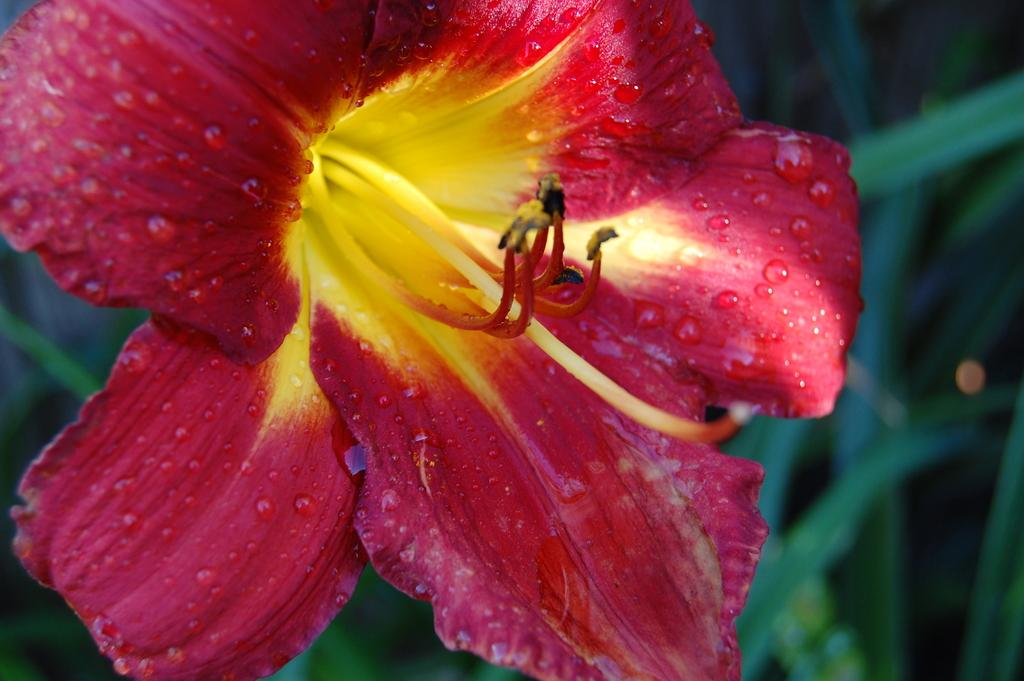What is the main subject of the image? There is a flower in the image. What else can be seen in the background of the image? There are leaves visible in the background of the image. How would you describe the quality of the image? The image is blurry. What arithmetic problem is being solved by the cats in the image? There are no cats or arithmetic problems present in the image. How does the acoustics of the room affect the appearance of the flower in the image? The image does not provide any information about the acoustics of the room, and the appearance of the flower is not affected by acoustics. 